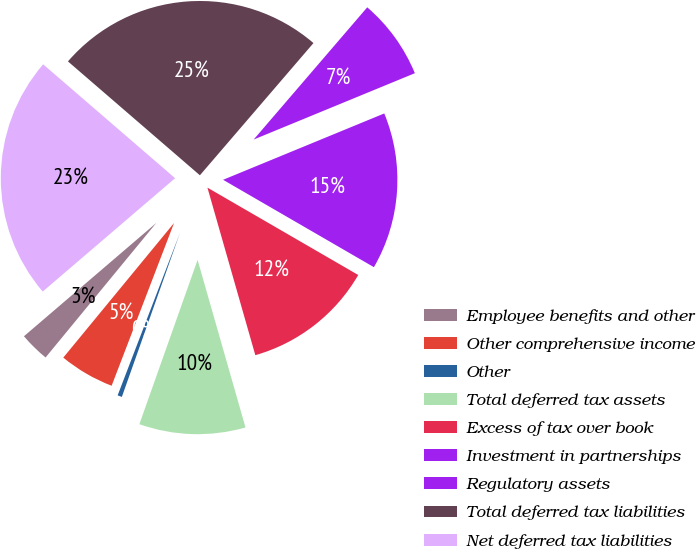<chart> <loc_0><loc_0><loc_500><loc_500><pie_chart><fcel>Employee benefits and other<fcel>Other comprehensive income<fcel>Other<fcel>Total deferred tax assets<fcel>Excess of tax over book<fcel>Investment in partnerships<fcel>Regulatory assets<fcel>Total deferred tax liabilities<fcel>Net deferred tax liabilities<nl><fcel>2.77%<fcel>5.13%<fcel>0.41%<fcel>9.85%<fcel>12.21%<fcel>14.57%<fcel>7.49%<fcel>24.96%<fcel>22.6%<nl></chart> 